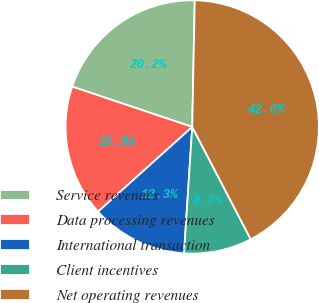<chart> <loc_0><loc_0><loc_500><loc_500><pie_chart><fcel>Service revenues<fcel>Data processing revenues<fcel>International transaction<fcel>Client incentives<fcel>Net operating revenues<nl><fcel>20.16%<fcel>16.82%<fcel>12.31%<fcel>8.67%<fcel>42.05%<nl></chart> 